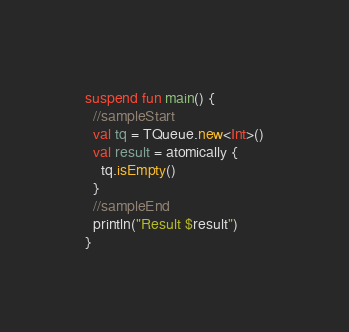<code> <loc_0><loc_0><loc_500><loc_500><_Kotlin_>
suspend fun main() {
  //sampleStart
  val tq = TQueue.new<Int>()
  val result = atomically {
    tq.isEmpty()
  }
  //sampleEnd
  println("Result $result")
}
</code> 